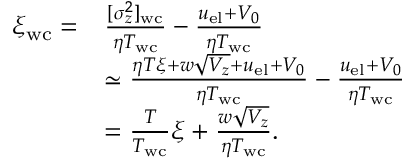<formula> <loc_0><loc_0><loc_500><loc_500>\begin{array} { r l } { \xi _ { w c } = } & { \frac { [ \sigma _ { z } ^ { 2 } ] _ { w c } } { \eta T _ { w c } } - \frac { u _ { e l } + V _ { 0 } } { \eta T _ { w c } } } \\ & { \simeq \frac { \eta T \xi + w \sqrt { V _ { z } } + u _ { e l } + V _ { 0 } } { \eta T _ { w c } } - \frac { u _ { e l } + V _ { 0 } } { \eta T _ { w c } } } \\ & { = \frac { T } { T _ { w c } } \xi + \frac { w \sqrt { V _ { z } } } { \eta T _ { w c } } . } \end{array}</formula> 